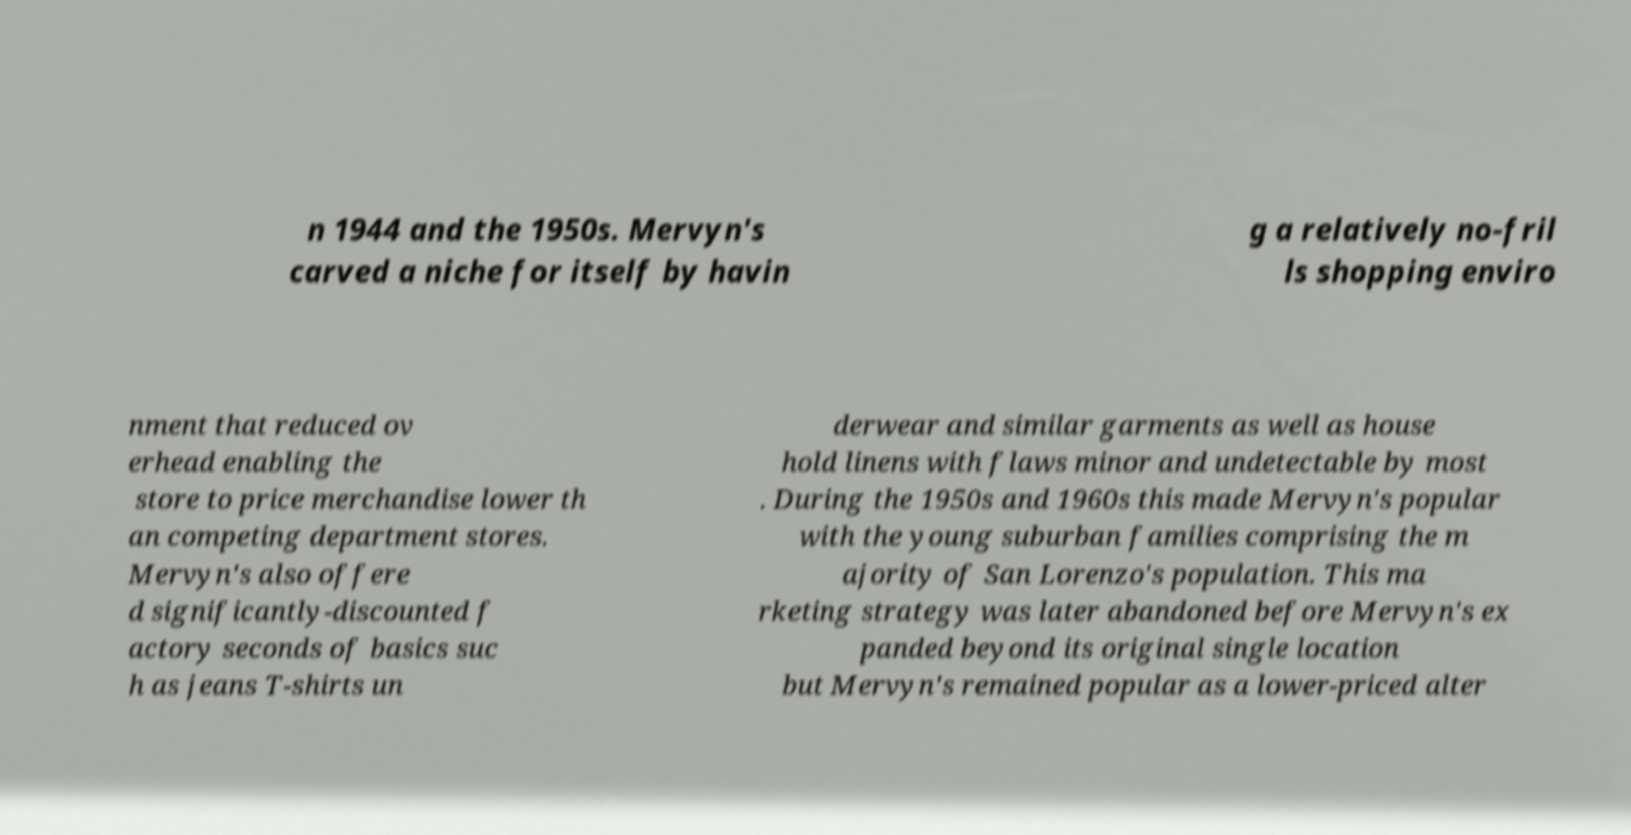Could you extract and type out the text from this image? n 1944 and the 1950s. Mervyn's carved a niche for itself by havin g a relatively no-fril ls shopping enviro nment that reduced ov erhead enabling the store to price merchandise lower th an competing department stores. Mervyn's also offere d significantly-discounted f actory seconds of basics suc h as jeans T-shirts un derwear and similar garments as well as house hold linens with flaws minor and undetectable by most . During the 1950s and 1960s this made Mervyn's popular with the young suburban families comprising the m ajority of San Lorenzo's population. This ma rketing strategy was later abandoned before Mervyn's ex panded beyond its original single location but Mervyn's remained popular as a lower-priced alter 